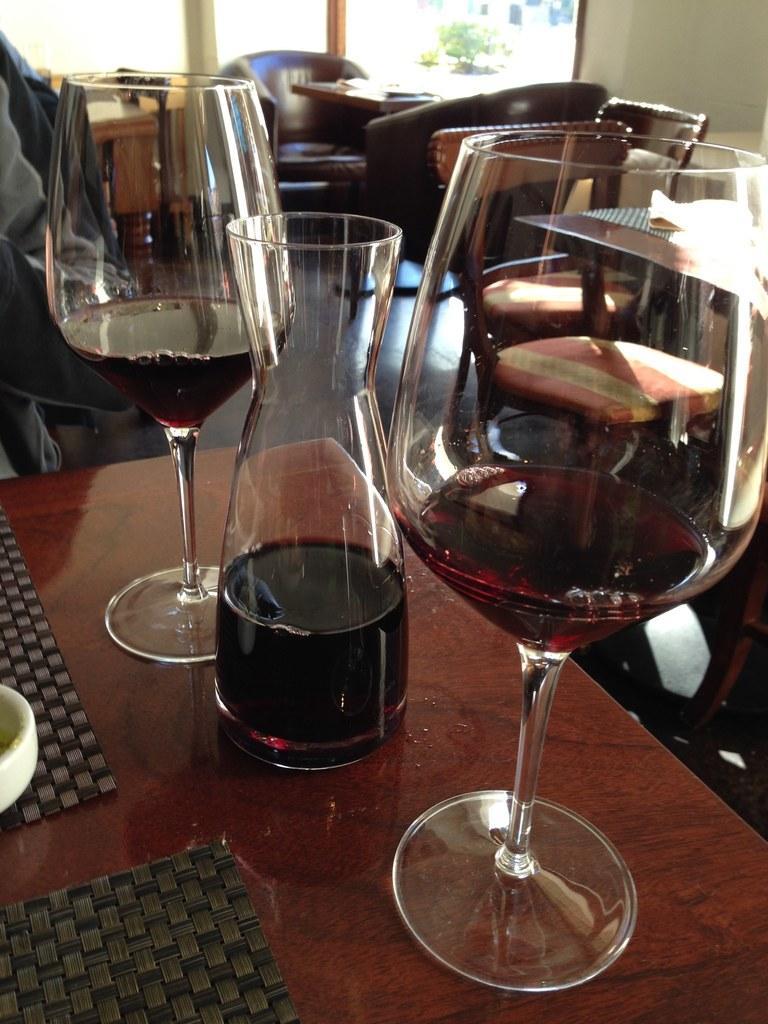How would you summarize this image in a sentence or two? In this image, we can see wine in the glasses and there are mars and some other objects on the tables and we can see chairs and a coat and there is a wall and a window, through the glass we can see plants. 